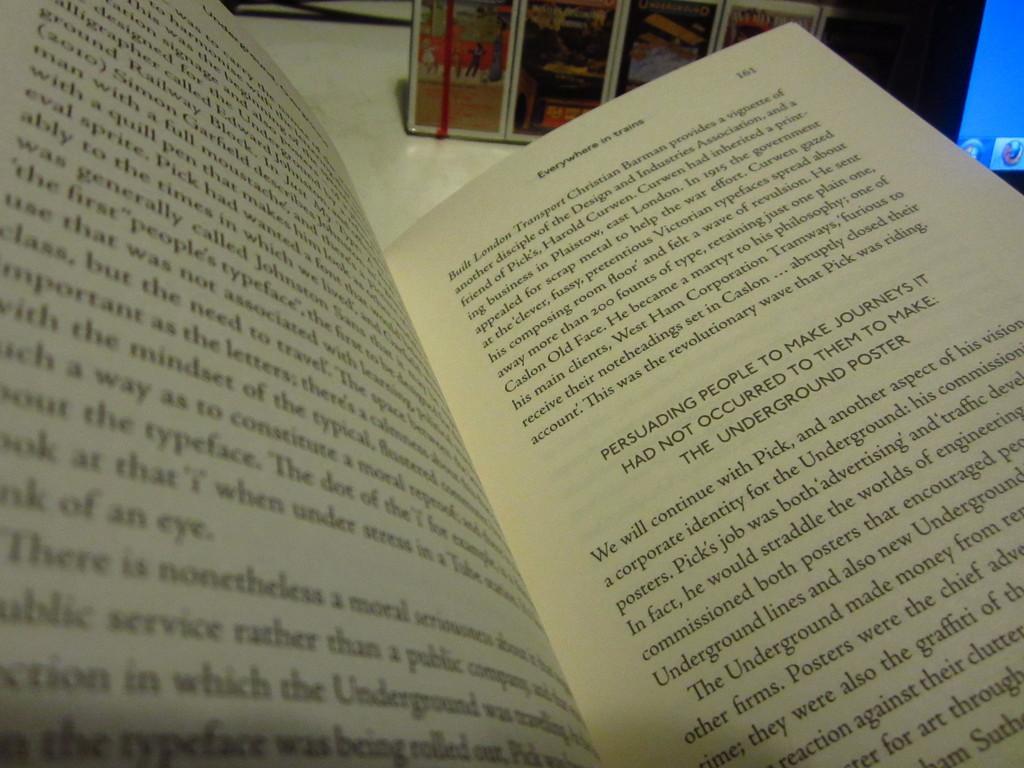<image>
Create a compact narrative representing the image presented. A booked called Everywhere in Trains is opened to page 161 